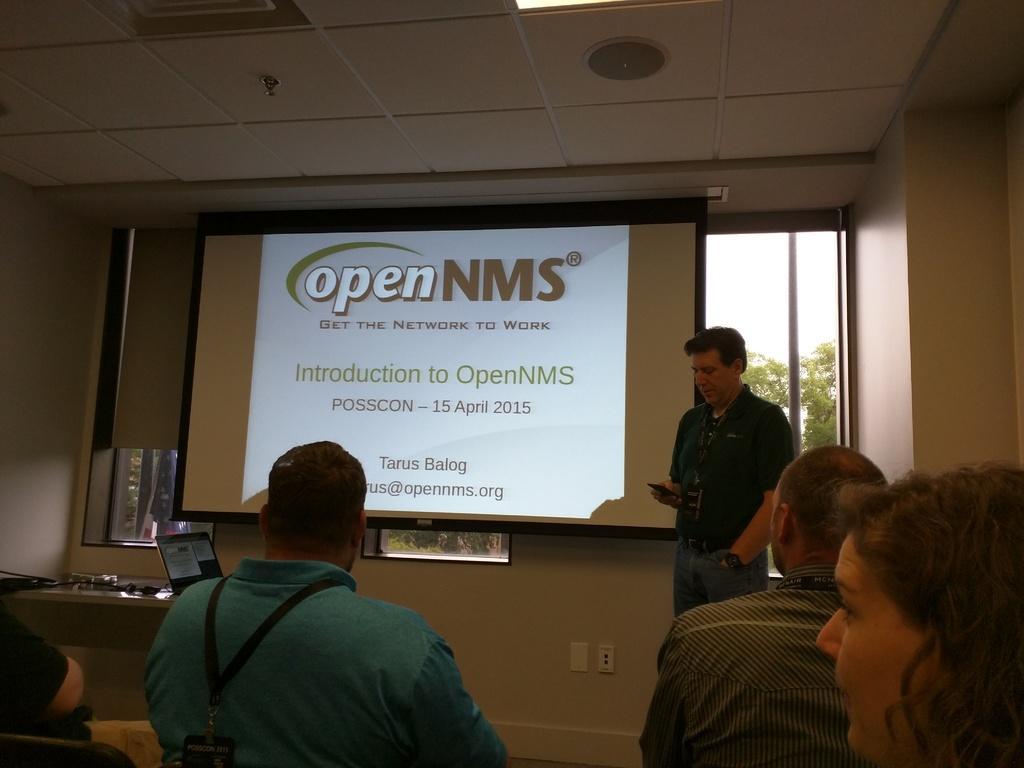Describe this image in one or two sentences. In this image there are some persons. In the background of the image there is a screen, glass window, a person and other objects. Through the glass window we can see trees and the sky. At the top of the image there is the ceiling with light. 